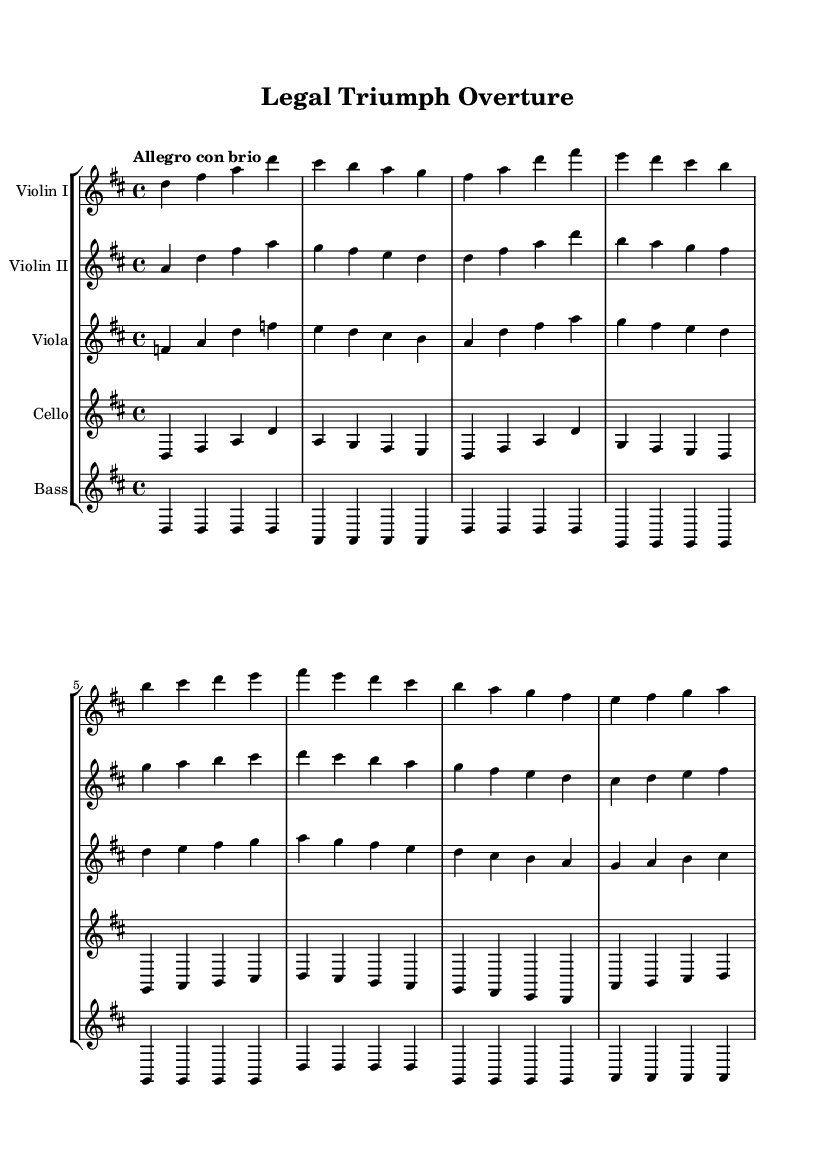What is the key signature of this music? The key signature is indicated at the beginning of the score. In this case, there are two sharps, which represent F# and C#. This corresponds to the key of D major.
Answer: D major What is the time signature of this piece? The time signature appears at the beginning of the staff, represented by the numbers arranged as a fraction. Here, it is shown as 4 over 4, indicating a common time signature with four beats in each measure.
Answer: 4/4 What is the tempo marking for this composition? The tempo marking is generally placed above the staff. In this score, "Allegro con brio" indicates the piece should be played fast and with spirit.
Answer: Allegro con brio How many measures are present in the first violin part? By counting the groupings of the note values, we can determine the number of measures. The violin I part consists of eight measures based on the layout of the written notes.
Answer: 8 Which instruments are included in this orchestral score? The score lists the names of the instruments directly above their respective staffs. The instruments included are Violin I, Violin II, Viola, Cello, and Bass.
Answer: Violin I, Violin II, Viola, Cello, Bass What is the last note of the cello part? The last note in the cello part can be found at the end of the line of notes. After reviewing the notation, the last note is a D.
Answer: D How many sharps are present in the key signature? The key signature shows two sharps identified as F# and C#. Each sharp corresponds to a specific note, contributing to the overall tonality.
Answer: 2 